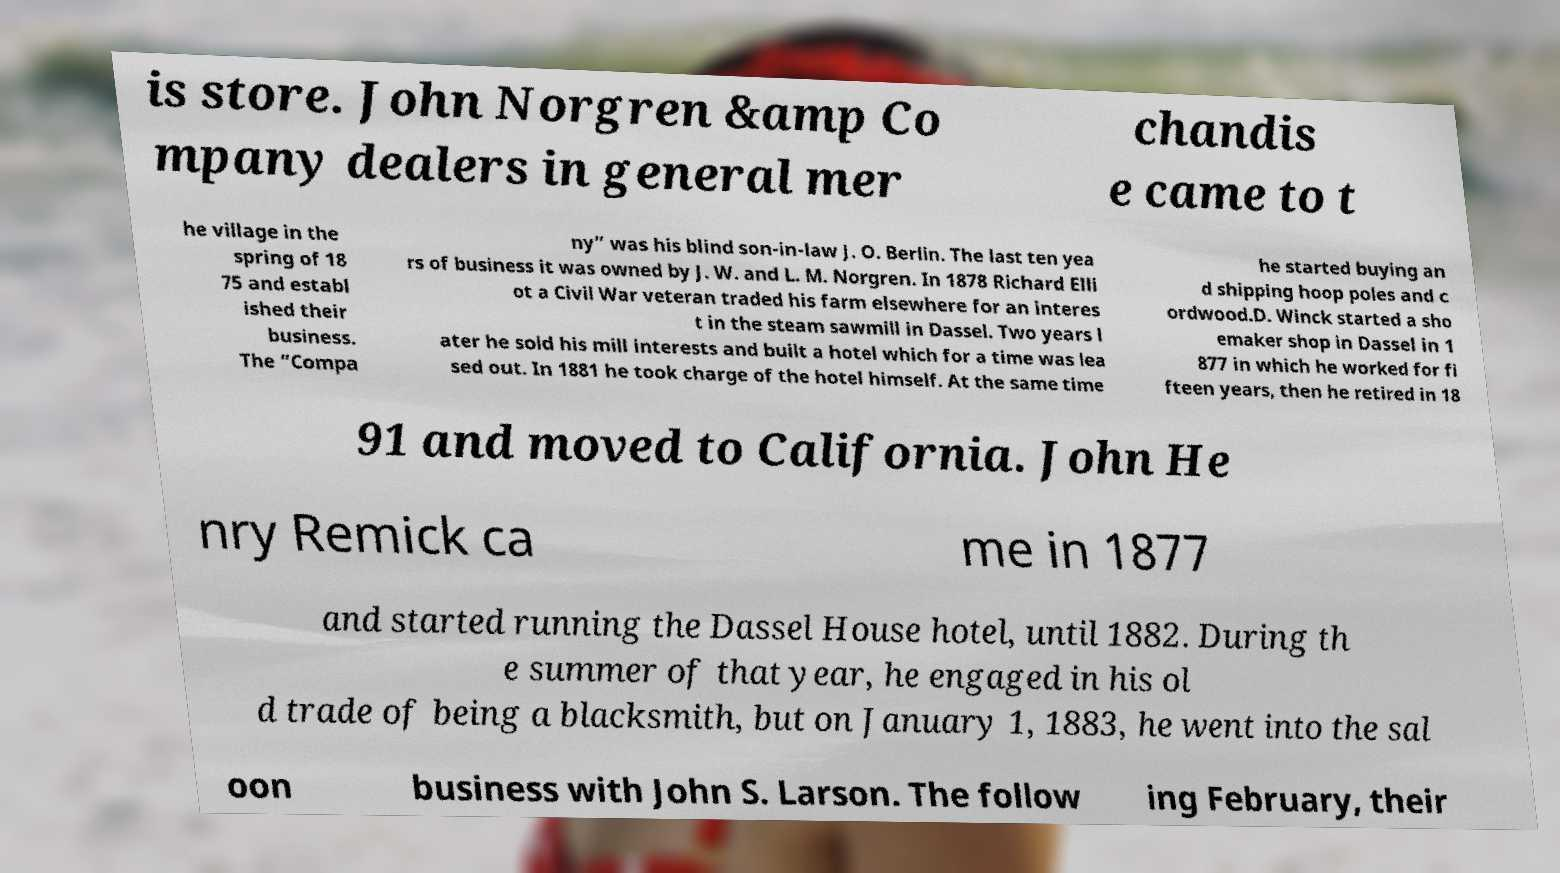For documentation purposes, I need the text within this image transcribed. Could you provide that? is store. John Norgren &amp Co mpany dealers in general mer chandis e came to t he village in the spring of 18 75 and establ ished their business. The “Compa ny” was his blind son-in-law J. O. Berlin. The last ten yea rs of business it was owned by J. W. and L. M. Norgren. In 1878 Richard Elli ot a Civil War veteran traded his farm elsewhere for an interes t in the steam sawmill in Dassel. Two years l ater he sold his mill interests and built a hotel which for a time was lea sed out. In 1881 he took charge of the hotel himself. At the same time he started buying an d shipping hoop poles and c ordwood.D. Winck started a sho emaker shop in Dassel in 1 877 in which he worked for fi fteen years, then he retired in 18 91 and moved to California. John He nry Remick ca me in 1877 and started running the Dassel House hotel, until 1882. During th e summer of that year, he engaged in his ol d trade of being a blacksmith, but on January 1, 1883, he went into the sal oon business with John S. Larson. The follow ing February, their 